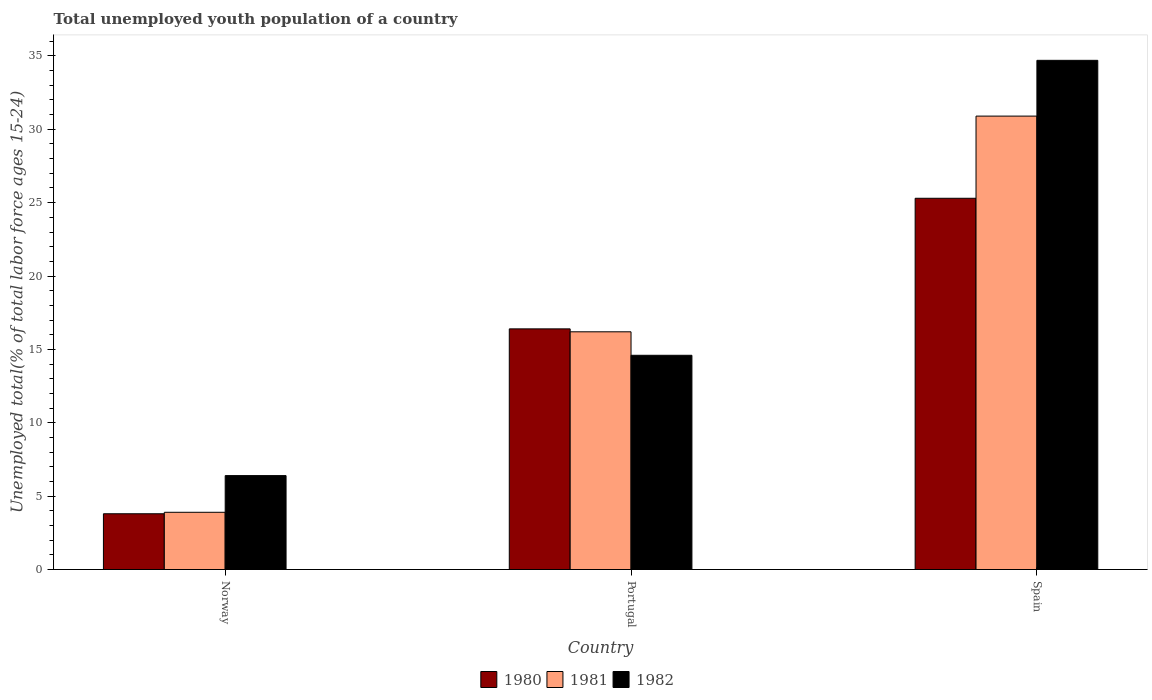How many different coloured bars are there?
Provide a succinct answer. 3. How many groups of bars are there?
Offer a terse response. 3. Are the number of bars per tick equal to the number of legend labels?
Keep it short and to the point. Yes. How many bars are there on the 1st tick from the right?
Your response must be concise. 3. What is the label of the 2nd group of bars from the left?
Offer a terse response. Portugal. In how many cases, is the number of bars for a given country not equal to the number of legend labels?
Your response must be concise. 0. What is the percentage of total unemployed youth population of a country in 1980 in Norway?
Provide a short and direct response. 3.8. Across all countries, what is the maximum percentage of total unemployed youth population of a country in 1981?
Give a very brief answer. 30.9. Across all countries, what is the minimum percentage of total unemployed youth population of a country in 1981?
Provide a short and direct response. 3.9. In which country was the percentage of total unemployed youth population of a country in 1980 maximum?
Offer a terse response. Spain. What is the total percentage of total unemployed youth population of a country in 1980 in the graph?
Keep it short and to the point. 45.5. What is the difference between the percentage of total unemployed youth population of a country in 1980 in Norway and that in Portugal?
Your response must be concise. -12.6. What is the difference between the percentage of total unemployed youth population of a country in 1982 in Norway and the percentage of total unemployed youth population of a country in 1981 in Spain?
Provide a succinct answer. -24.5. What is the average percentage of total unemployed youth population of a country in 1982 per country?
Keep it short and to the point. 18.57. What is the difference between the percentage of total unemployed youth population of a country of/in 1980 and percentage of total unemployed youth population of a country of/in 1981 in Portugal?
Your response must be concise. 0.2. In how many countries, is the percentage of total unemployed youth population of a country in 1980 greater than 22 %?
Offer a terse response. 1. What is the ratio of the percentage of total unemployed youth population of a country in 1981 in Portugal to that in Spain?
Ensure brevity in your answer.  0.52. Is the percentage of total unemployed youth population of a country in 1981 in Portugal less than that in Spain?
Offer a very short reply. Yes. What is the difference between the highest and the second highest percentage of total unemployed youth population of a country in 1982?
Your answer should be very brief. 20.1. What is the difference between the highest and the lowest percentage of total unemployed youth population of a country in 1982?
Make the answer very short. 28.3. In how many countries, is the percentage of total unemployed youth population of a country in 1982 greater than the average percentage of total unemployed youth population of a country in 1982 taken over all countries?
Offer a terse response. 1. Is the sum of the percentage of total unemployed youth population of a country in 1980 in Portugal and Spain greater than the maximum percentage of total unemployed youth population of a country in 1981 across all countries?
Offer a terse response. Yes. What does the 3rd bar from the left in Portugal represents?
Your answer should be very brief. 1982. What does the 2nd bar from the right in Spain represents?
Give a very brief answer. 1981. Is it the case that in every country, the sum of the percentage of total unemployed youth population of a country in 1980 and percentage of total unemployed youth population of a country in 1982 is greater than the percentage of total unemployed youth population of a country in 1981?
Give a very brief answer. Yes. Are all the bars in the graph horizontal?
Ensure brevity in your answer.  No. What is the difference between two consecutive major ticks on the Y-axis?
Keep it short and to the point. 5. Are the values on the major ticks of Y-axis written in scientific E-notation?
Give a very brief answer. No. Does the graph contain any zero values?
Your response must be concise. No. How are the legend labels stacked?
Provide a short and direct response. Horizontal. What is the title of the graph?
Make the answer very short. Total unemployed youth population of a country. Does "1961" appear as one of the legend labels in the graph?
Provide a succinct answer. No. What is the label or title of the Y-axis?
Give a very brief answer. Unemployed total(% of total labor force ages 15-24). What is the Unemployed total(% of total labor force ages 15-24) of 1980 in Norway?
Your answer should be compact. 3.8. What is the Unemployed total(% of total labor force ages 15-24) in 1981 in Norway?
Offer a terse response. 3.9. What is the Unemployed total(% of total labor force ages 15-24) of 1982 in Norway?
Provide a succinct answer. 6.4. What is the Unemployed total(% of total labor force ages 15-24) of 1980 in Portugal?
Your answer should be very brief. 16.4. What is the Unemployed total(% of total labor force ages 15-24) of 1981 in Portugal?
Make the answer very short. 16.2. What is the Unemployed total(% of total labor force ages 15-24) of 1982 in Portugal?
Your response must be concise. 14.6. What is the Unemployed total(% of total labor force ages 15-24) in 1980 in Spain?
Offer a terse response. 25.3. What is the Unemployed total(% of total labor force ages 15-24) of 1981 in Spain?
Your answer should be compact. 30.9. What is the Unemployed total(% of total labor force ages 15-24) of 1982 in Spain?
Offer a very short reply. 34.7. Across all countries, what is the maximum Unemployed total(% of total labor force ages 15-24) of 1980?
Provide a short and direct response. 25.3. Across all countries, what is the maximum Unemployed total(% of total labor force ages 15-24) in 1981?
Provide a short and direct response. 30.9. Across all countries, what is the maximum Unemployed total(% of total labor force ages 15-24) of 1982?
Provide a short and direct response. 34.7. Across all countries, what is the minimum Unemployed total(% of total labor force ages 15-24) in 1980?
Provide a succinct answer. 3.8. Across all countries, what is the minimum Unemployed total(% of total labor force ages 15-24) in 1981?
Your answer should be compact. 3.9. Across all countries, what is the minimum Unemployed total(% of total labor force ages 15-24) in 1982?
Ensure brevity in your answer.  6.4. What is the total Unemployed total(% of total labor force ages 15-24) of 1980 in the graph?
Keep it short and to the point. 45.5. What is the total Unemployed total(% of total labor force ages 15-24) in 1981 in the graph?
Offer a very short reply. 51. What is the total Unemployed total(% of total labor force ages 15-24) of 1982 in the graph?
Provide a short and direct response. 55.7. What is the difference between the Unemployed total(% of total labor force ages 15-24) of 1982 in Norway and that in Portugal?
Provide a short and direct response. -8.2. What is the difference between the Unemployed total(% of total labor force ages 15-24) of 1980 in Norway and that in Spain?
Ensure brevity in your answer.  -21.5. What is the difference between the Unemployed total(% of total labor force ages 15-24) of 1981 in Norway and that in Spain?
Your response must be concise. -27. What is the difference between the Unemployed total(% of total labor force ages 15-24) of 1982 in Norway and that in Spain?
Provide a succinct answer. -28.3. What is the difference between the Unemployed total(% of total labor force ages 15-24) of 1980 in Portugal and that in Spain?
Keep it short and to the point. -8.9. What is the difference between the Unemployed total(% of total labor force ages 15-24) of 1981 in Portugal and that in Spain?
Provide a short and direct response. -14.7. What is the difference between the Unemployed total(% of total labor force ages 15-24) in 1982 in Portugal and that in Spain?
Your answer should be compact. -20.1. What is the difference between the Unemployed total(% of total labor force ages 15-24) in 1980 in Norway and the Unemployed total(% of total labor force ages 15-24) in 1982 in Portugal?
Make the answer very short. -10.8. What is the difference between the Unemployed total(% of total labor force ages 15-24) of 1981 in Norway and the Unemployed total(% of total labor force ages 15-24) of 1982 in Portugal?
Offer a terse response. -10.7. What is the difference between the Unemployed total(% of total labor force ages 15-24) in 1980 in Norway and the Unemployed total(% of total labor force ages 15-24) in 1981 in Spain?
Your answer should be very brief. -27.1. What is the difference between the Unemployed total(% of total labor force ages 15-24) in 1980 in Norway and the Unemployed total(% of total labor force ages 15-24) in 1982 in Spain?
Make the answer very short. -30.9. What is the difference between the Unemployed total(% of total labor force ages 15-24) in 1981 in Norway and the Unemployed total(% of total labor force ages 15-24) in 1982 in Spain?
Make the answer very short. -30.8. What is the difference between the Unemployed total(% of total labor force ages 15-24) in 1980 in Portugal and the Unemployed total(% of total labor force ages 15-24) in 1982 in Spain?
Offer a very short reply. -18.3. What is the difference between the Unemployed total(% of total labor force ages 15-24) of 1981 in Portugal and the Unemployed total(% of total labor force ages 15-24) of 1982 in Spain?
Offer a terse response. -18.5. What is the average Unemployed total(% of total labor force ages 15-24) in 1980 per country?
Give a very brief answer. 15.17. What is the average Unemployed total(% of total labor force ages 15-24) in 1981 per country?
Give a very brief answer. 17. What is the average Unemployed total(% of total labor force ages 15-24) in 1982 per country?
Provide a short and direct response. 18.57. What is the difference between the Unemployed total(% of total labor force ages 15-24) of 1980 and Unemployed total(% of total labor force ages 15-24) of 1981 in Norway?
Ensure brevity in your answer.  -0.1. What is the difference between the Unemployed total(% of total labor force ages 15-24) of 1981 and Unemployed total(% of total labor force ages 15-24) of 1982 in Norway?
Give a very brief answer. -2.5. What is the difference between the Unemployed total(% of total labor force ages 15-24) in 1980 and Unemployed total(% of total labor force ages 15-24) in 1982 in Portugal?
Keep it short and to the point. 1.8. What is the difference between the Unemployed total(% of total labor force ages 15-24) of 1980 and Unemployed total(% of total labor force ages 15-24) of 1982 in Spain?
Provide a succinct answer. -9.4. What is the ratio of the Unemployed total(% of total labor force ages 15-24) of 1980 in Norway to that in Portugal?
Offer a terse response. 0.23. What is the ratio of the Unemployed total(% of total labor force ages 15-24) of 1981 in Norway to that in Portugal?
Keep it short and to the point. 0.24. What is the ratio of the Unemployed total(% of total labor force ages 15-24) of 1982 in Norway to that in Portugal?
Your answer should be compact. 0.44. What is the ratio of the Unemployed total(% of total labor force ages 15-24) of 1980 in Norway to that in Spain?
Provide a succinct answer. 0.15. What is the ratio of the Unemployed total(% of total labor force ages 15-24) in 1981 in Norway to that in Spain?
Offer a very short reply. 0.13. What is the ratio of the Unemployed total(% of total labor force ages 15-24) in 1982 in Norway to that in Spain?
Keep it short and to the point. 0.18. What is the ratio of the Unemployed total(% of total labor force ages 15-24) in 1980 in Portugal to that in Spain?
Make the answer very short. 0.65. What is the ratio of the Unemployed total(% of total labor force ages 15-24) of 1981 in Portugal to that in Spain?
Keep it short and to the point. 0.52. What is the ratio of the Unemployed total(% of total labor force ages 15-24) of 1982 in Portugal to that in Spain?
Make the answer very short. 0.42. What is the difference between the highest and the second highest Unemployed total(% of total labor force ages 15-24) in 1980?
Your answer should be very brief. 8.9. What is the difference between the highest and the second highest Unemployed total(% of total labor force ages 15-24) of 1981?
Provide a short and direct response. 14.7. What is the difference between the highest and the second highest Unemployed total(% of total labor force ages 15-24) of 1982?
Provide a succinct answer. 20.1. What is the difference between the highest and the lowest Unemployed total(% of total labor force ages 15-24) of 1981?
Ensure brevity in your answer.  27. What is the difference between the highest and the lowest Unemployed total(% of total labor force ages 15-24) of 1982?
Make the answer very short. 28.3. 